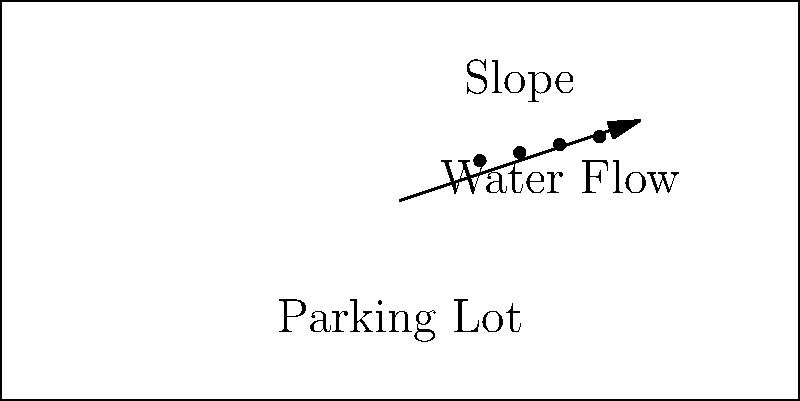As a novice programmer interested in autonomous vehicles, you're working on a project to optimize water drainage in parking lots. Given that the recommended slope for efficient water drainage in parking lots is between 1% and 5%, what would be the optimal slope percentage for a 50-meter wide parking lot if you want the water to drop 1.5 meters across its width? Let's approach this step-by-step:

1. We need to calculate the slope percentage using the given information.

2. The slope percentage is calculated using the formula:
   $$ \text{Slope (%)} = \frac{\text{Rise}}{\text{Run}} \times 100 $$

3. In this case:
   - Rise = 1.5 meters (the vertical drop)
   - Run = 50 meters (the width of the parking lot)

4. Let's plug these values into our formula:
   $$ \text{Slope (%)} = \frac{1.5 \text{ m}}{50 \text{ m}} \times 100 $$

5. Simplify:
   $$ \text{Slope (%)} = 0.03 \times 100 = 3\% $$

6. Check if this falls within the recommended range:
   - The calculated slope (3%) is between 1% and 5%, so it's within the recommended range.

7. For programming autonomous vehicles, this slope information could be used to adjust vehicle behavior in wet conditions or to plan optimal routes for water runoff avoidance.
Answer: 3% 